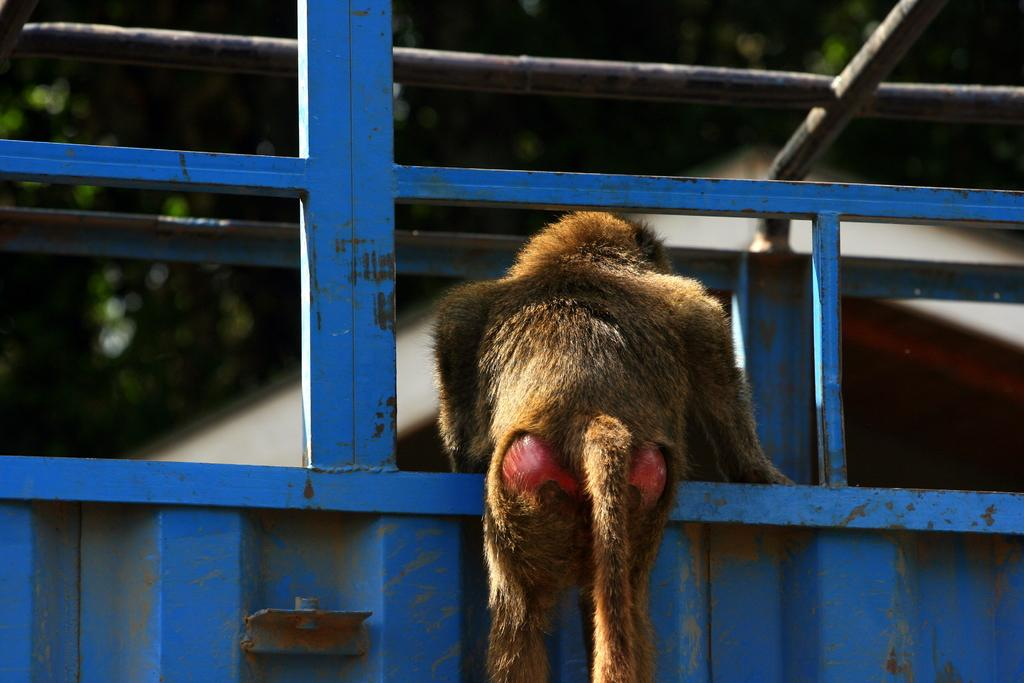What animal is present in the image? There is a monkey in the image. What is the monkey standing on? The monkey is on an iron object. Can you describe the background of the image? The background of the image is blurry. What type of tax is being discussed in the image? There is no discussion of tax in the image; it features a monkey on an iron object with a blurry background. 